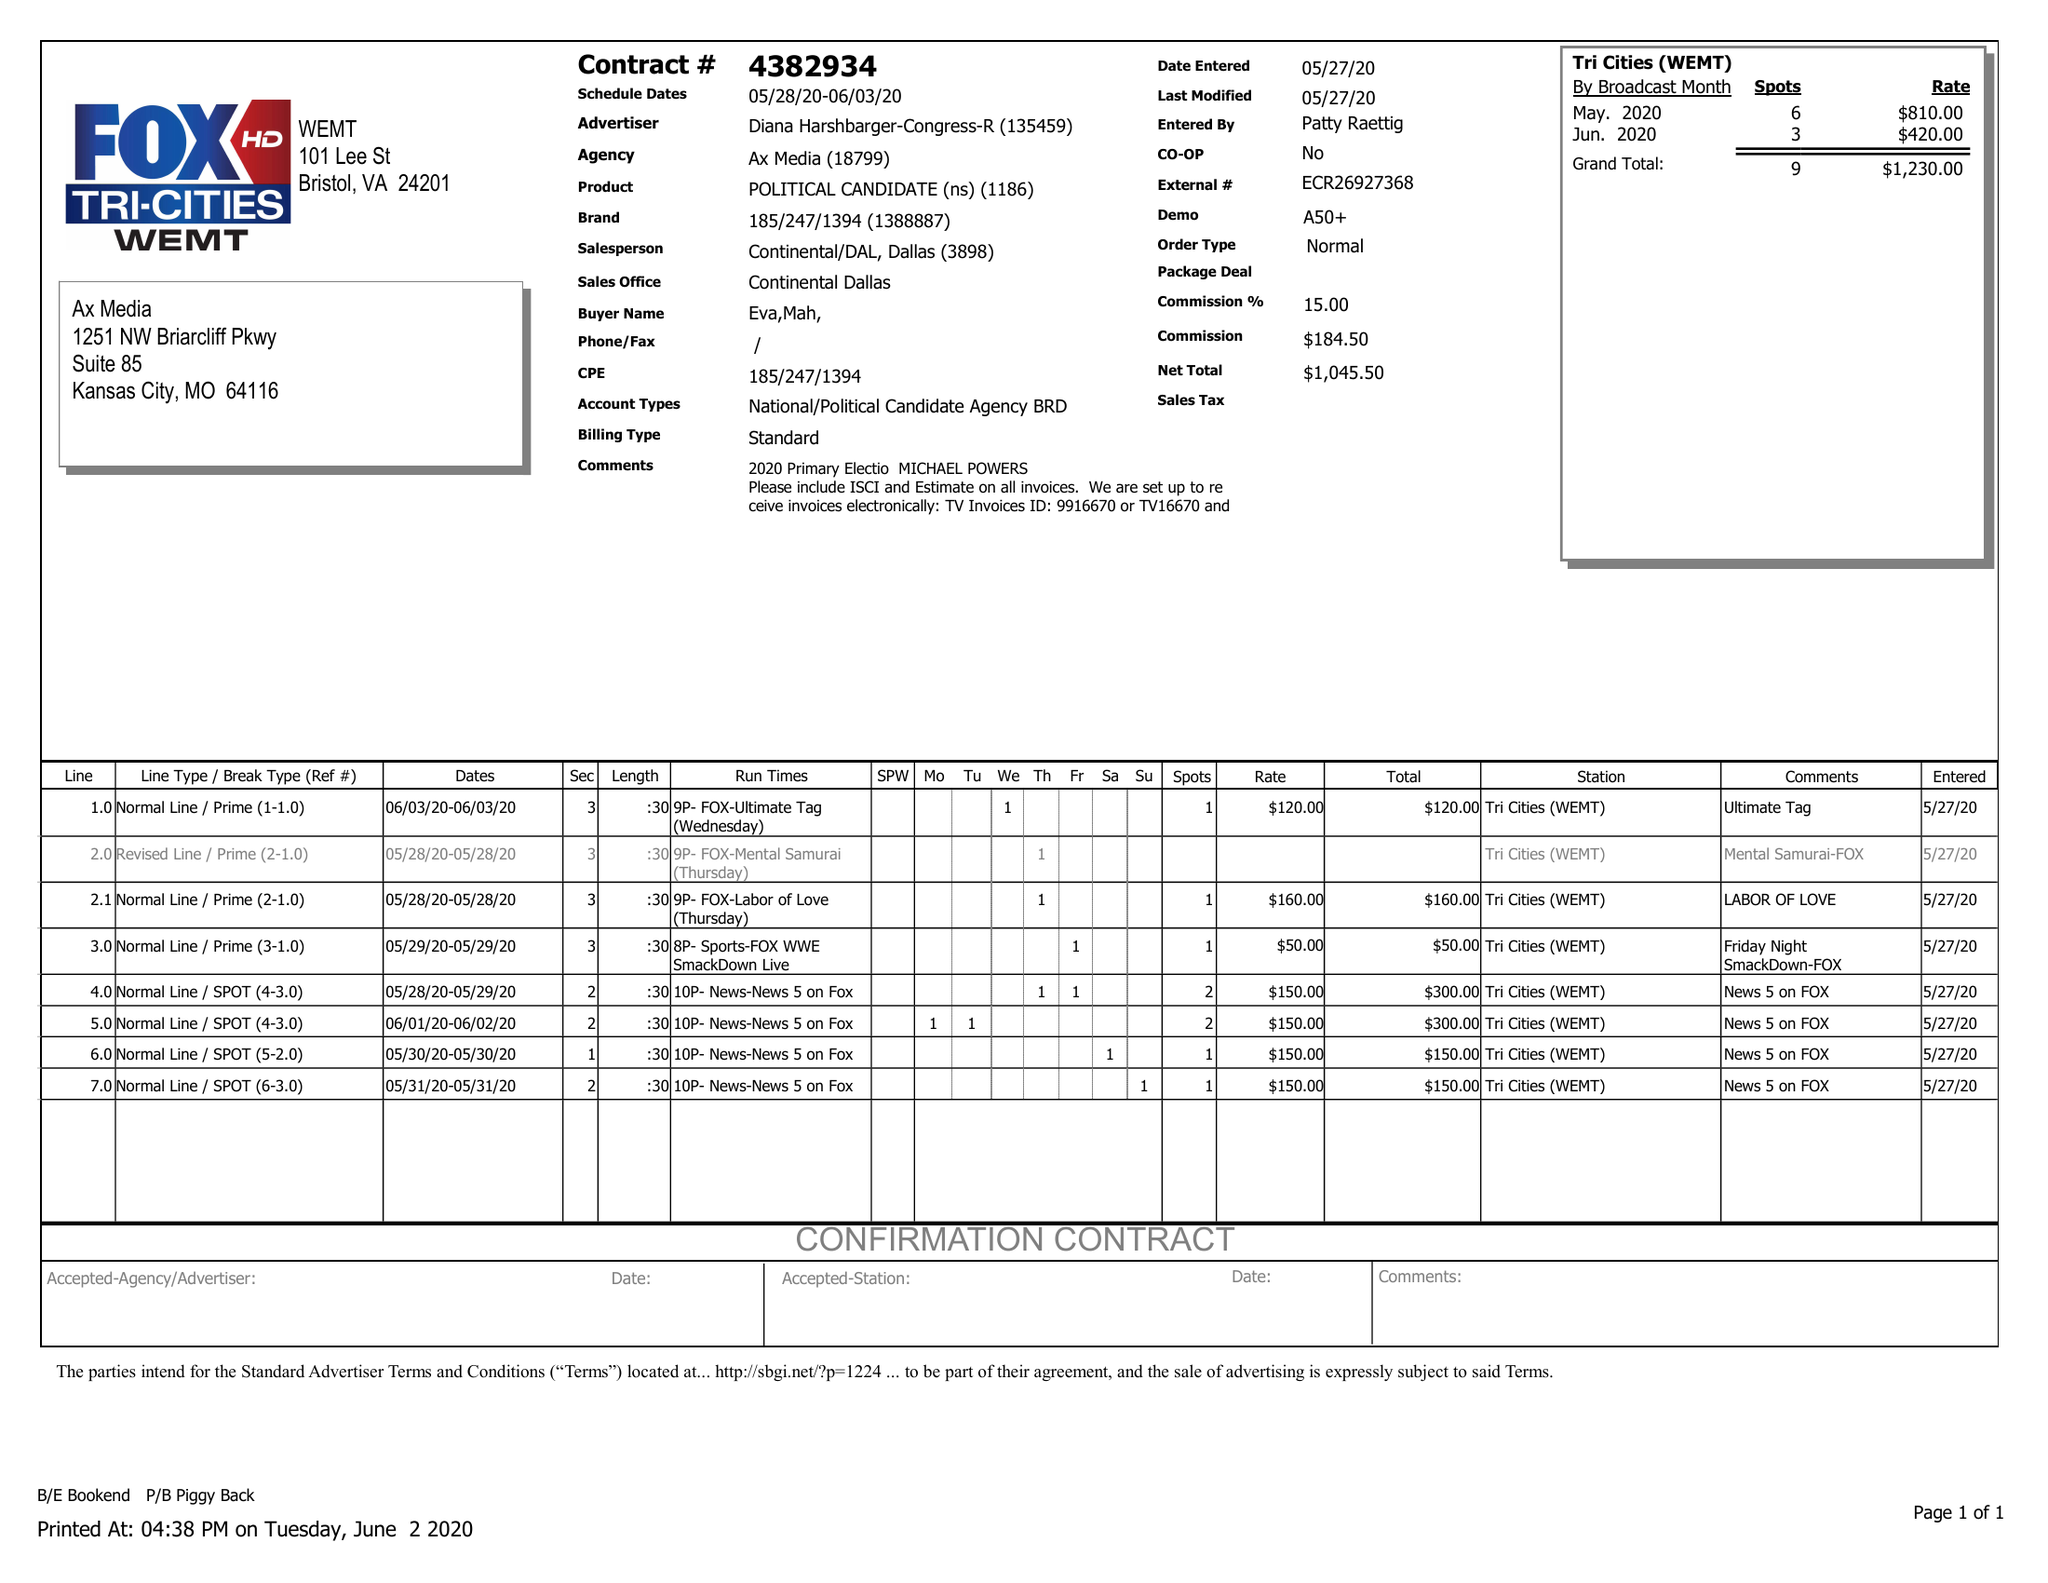What is the value for the gross_amount?
Answer the question using a single word or phrase. 1230.00 